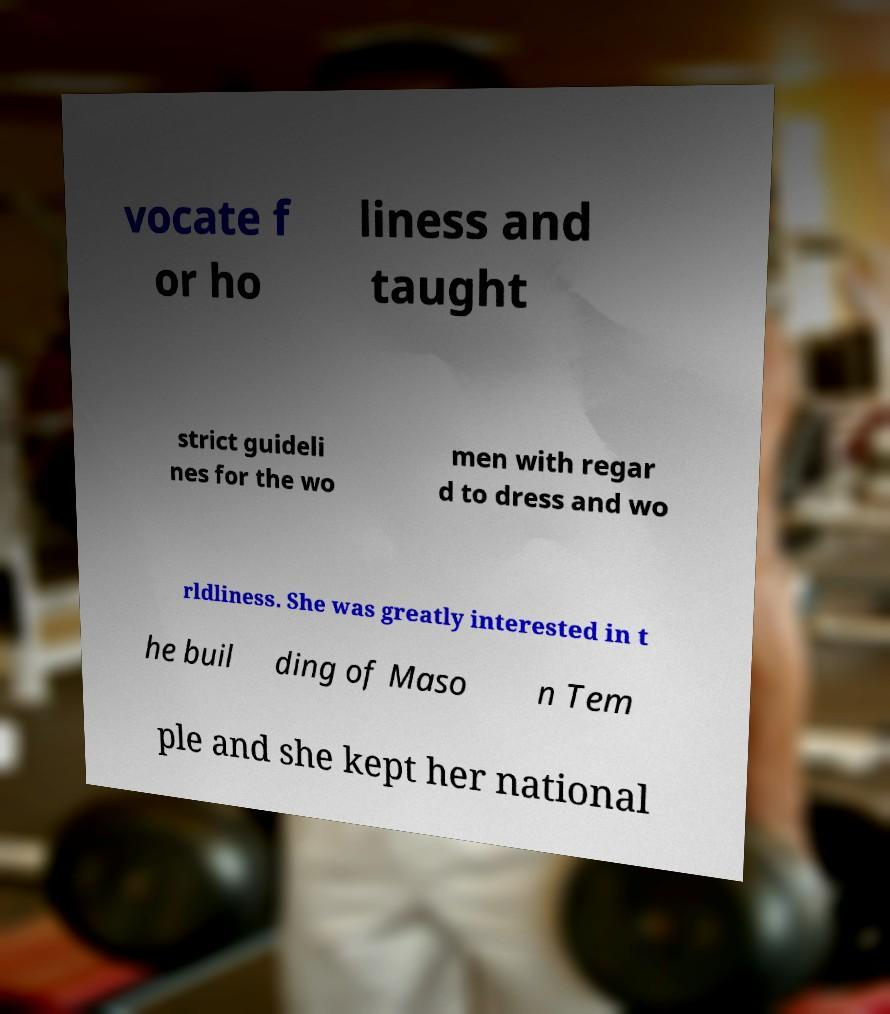Could you extract and type out the text from this image? vocate f or ho liness and taught strict guideli nes for the wo men with regar d to dress and wo rldliness. She was greatly interested in t he buil ding of Maso n Tem ple and she kept her national 